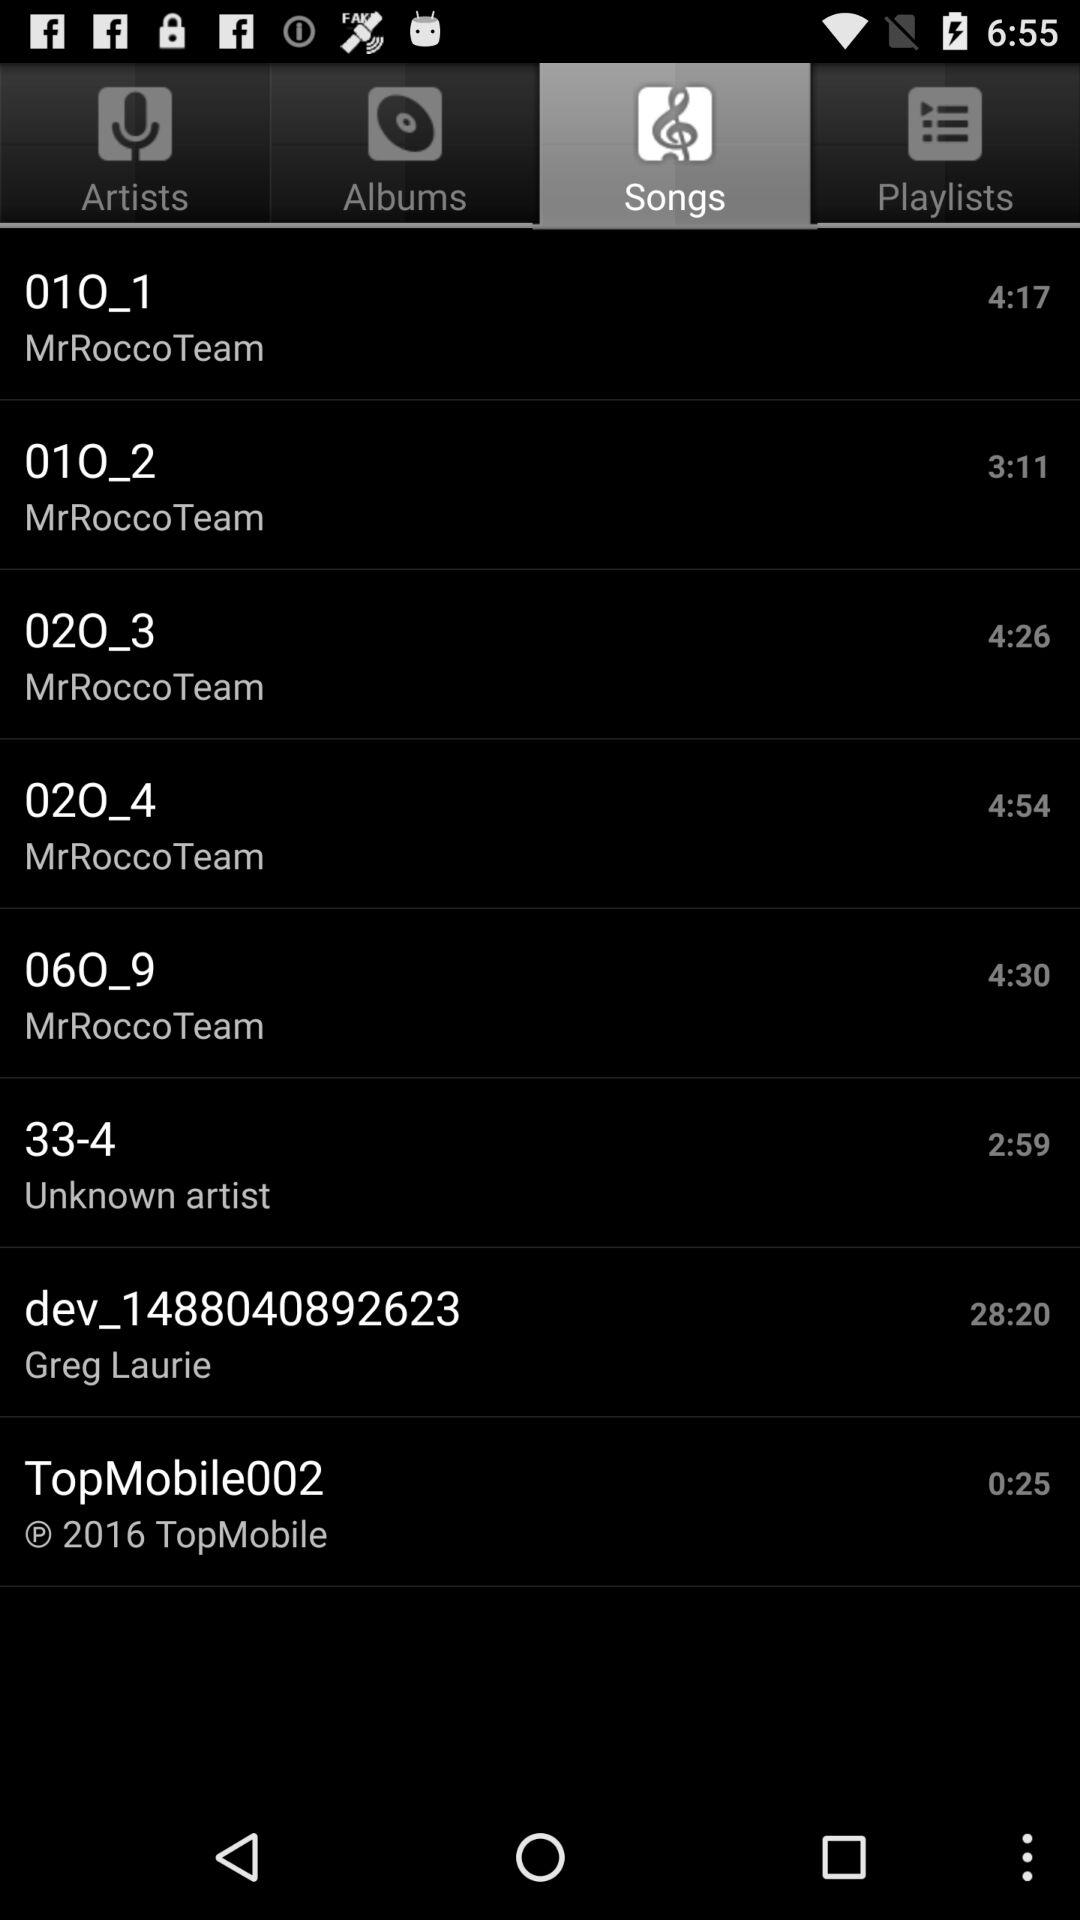Which tab is selected? The selected tab is "Songs". 